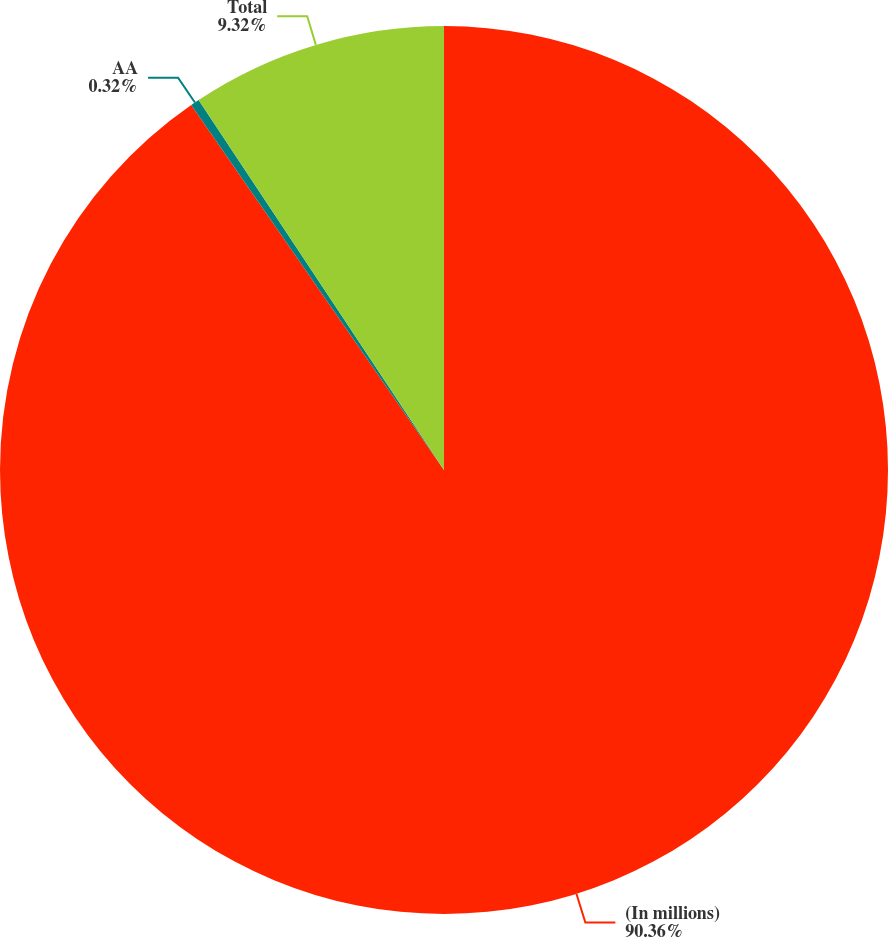Convert chart. <chart><loc_0><loc_0><loc_500><loc_500><pie_chart><fcel>(In millions)<fcel>AA<fcel>Total<nl><fcel>90.36%<fcel>0.32%<fcel>9.32%<nl></chart> 